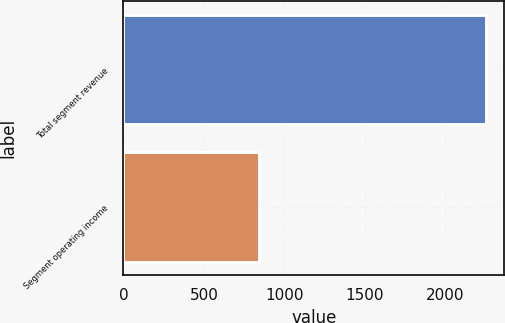Convert chart to OTSL. <chart><loc_0><loc_0><loc_500><loc_500><bar_chart><fcel>Total segment revenue<fcel>Segment operating income<nl><fcel>2253<fcel>843<nl></chart> 